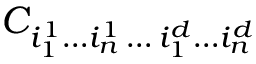Convert formula to latex. <formula><loc_0><loc_0><loc_500><loc_500>C _ { i _ { 1 } ^ { 1 } \dots i _ { n } ^ { 1 } \, \dots \, i _ { 1 } ^ { d } \dots i _ { n } ^ { d } }</formula> 